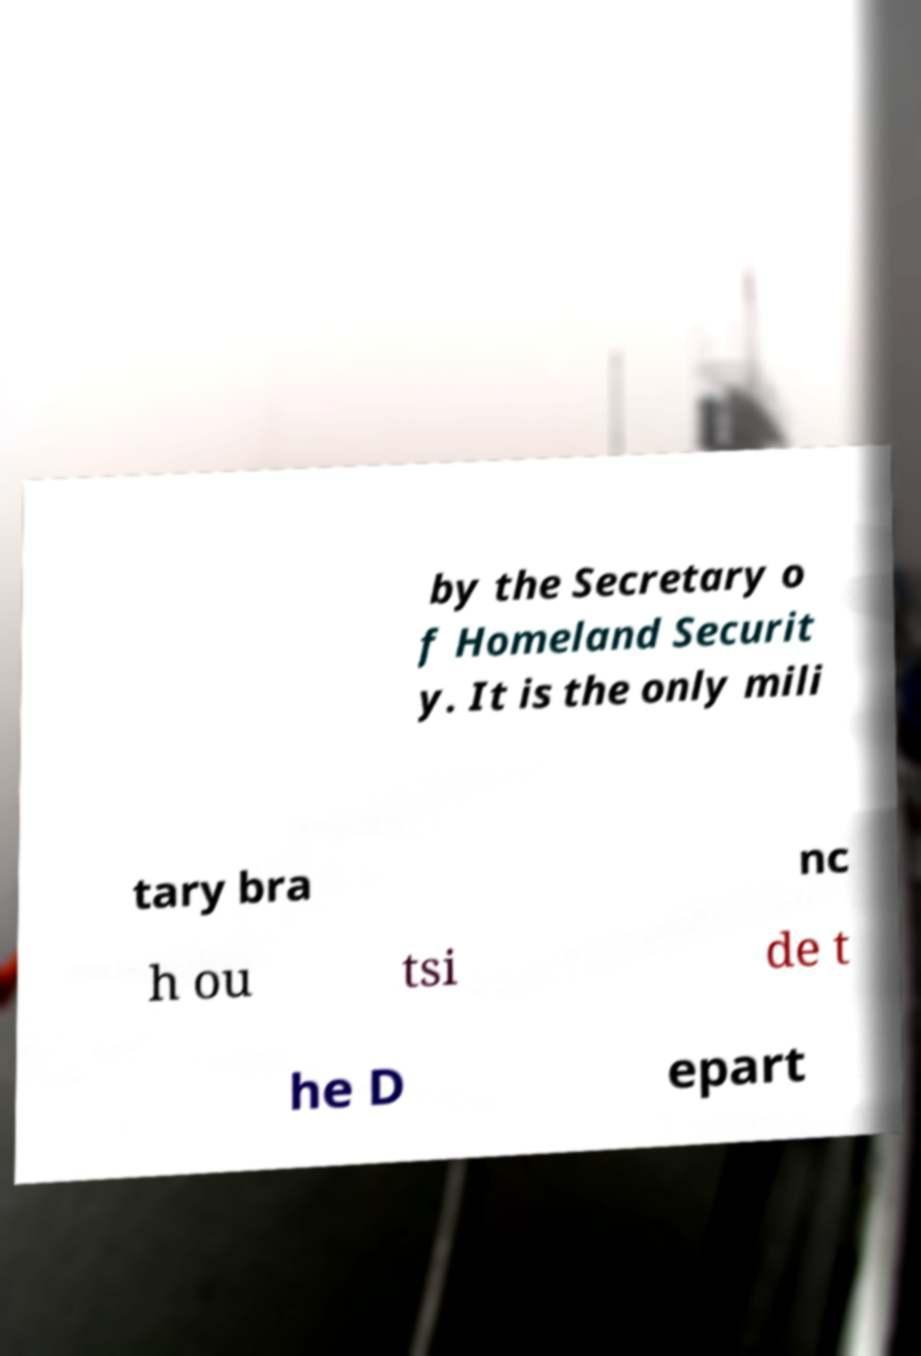Could you extract and type out the text from this image? by the Secretary o f Homeland Securit y. It is the only mili tary bra nc h ou tsi de t he D epart 